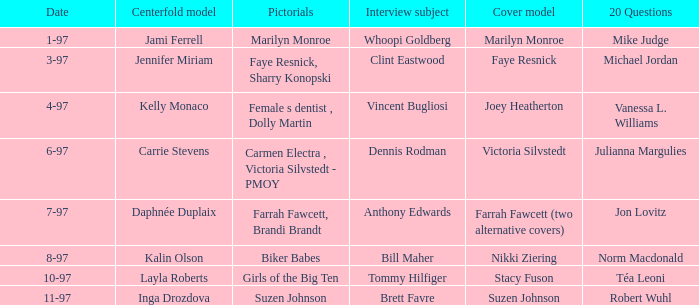Who was the centerfold model when a pictorial was done on marilyn monroe? Jami Ferrell. 